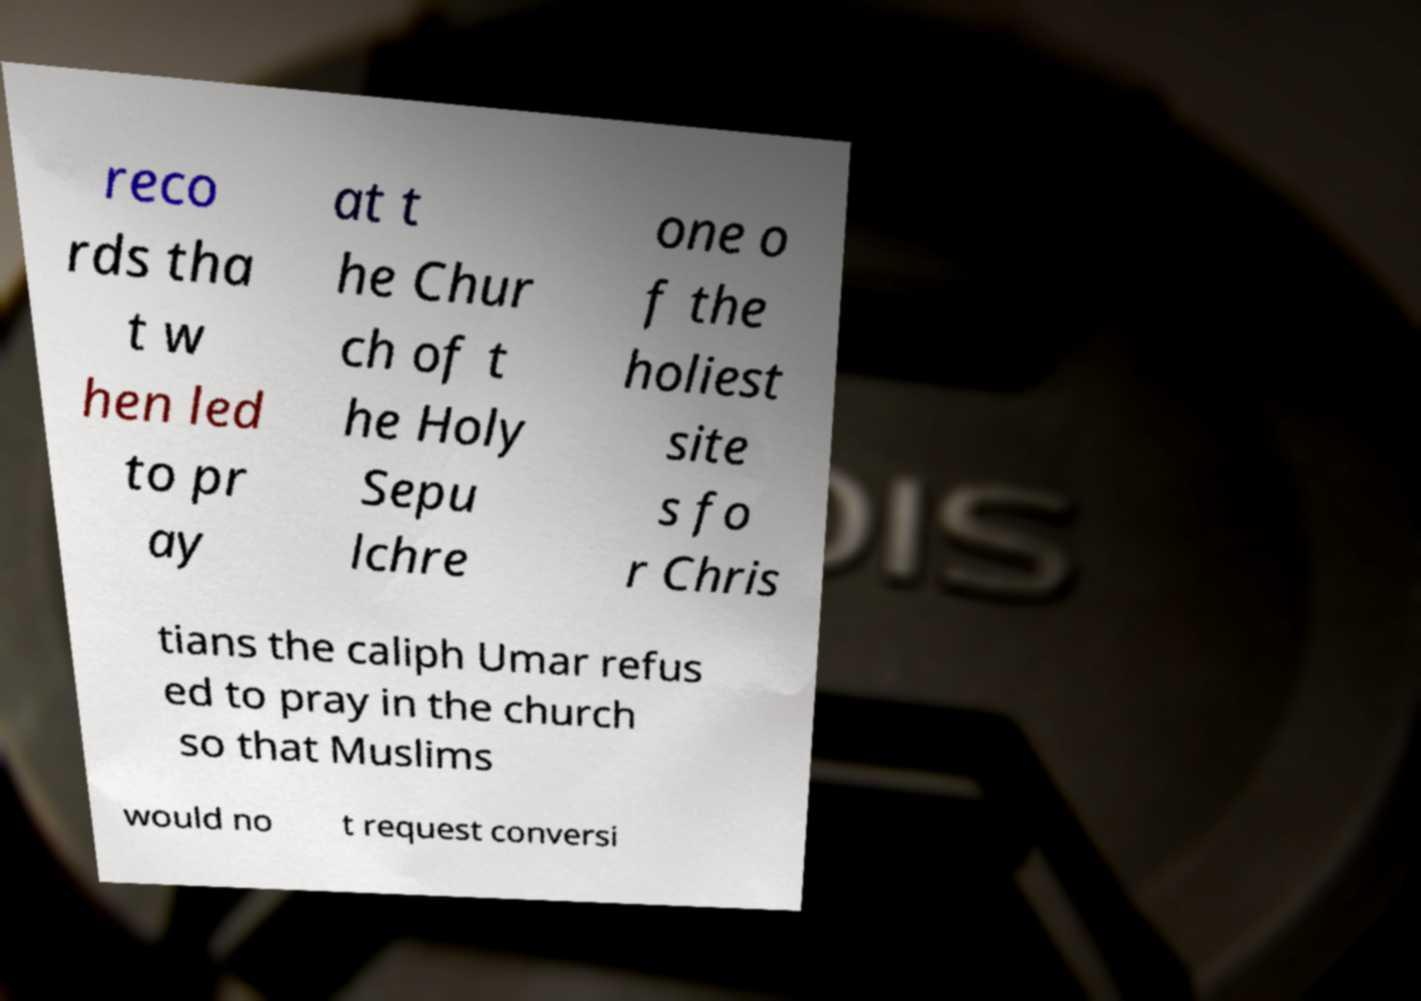What messages or text are displayed in this image? I need them in a readable, typed format. reco rds tha t w hen led to pr ay at t he Chur ch of t he Holy Sepu lchre one o f the holiest site s fo r Chris tians the caliph Umar refus ed to pray in the church so that Muslims would no t request conversi 